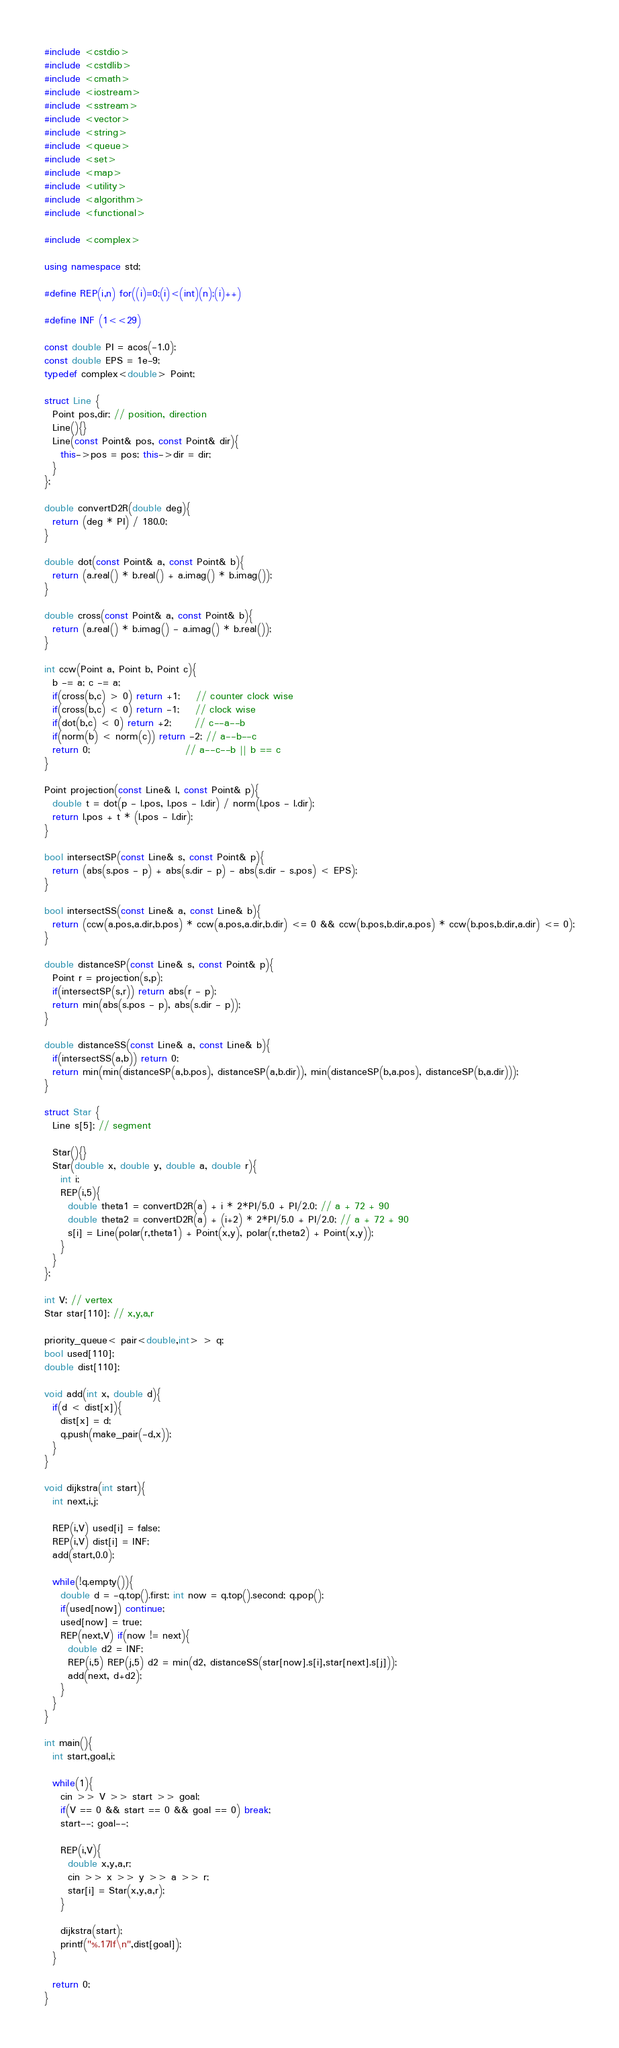<code> <loc_0><loc_0><loc_500><loc_500><_C++_>#include <cstdio>
#include <cstdlib>
#include <cmath>
#include <iostream>
#include <sstream>
#include <vector>
#include <string>
#include <queue>
#include <set>
#include <map>
#include <utility>
#include <algorithm>
#include <functional>

#include <complex>

using namespace std;

#define REP(i,n) for((i)=0;(i)<(int)(n);(i)++)

#define INF (1<<29)

const double PI = acos(-1.0);
const double EPS = 1e-9;
typedef complex<double> Point;

struct Line {
  Point pos,dir; // position, direction
  Line(){}
  Line(const Point& pos, const Point& dir){
    this->pos = pos; this->dir = dir;
  }
};

double convertD2R(double deg){
  return (deg * PI) / 180.0;
}

double dot(const Point& a, const Point& b){
  return (a.real() * b.real() + a.imag() * b.imag());
}

double cross(const Point& a, const Point& b){
  return (a.real() * b.imag() - a.imag() * b.real());
}

int ccw(Point a, Point b, Point c){
  b -= a; c -= a;
  if(cross(b,c) > 0) return +1;    // counter clock wise
  if(cross(b,c) < 0) return -1;    // clock wise
  if(dot(b,c) < 0) return +2;      // c--a--b
  if(norm(b) < norm(c)) return -2; // a--b--c
  return 0;                        // a--c--b || b == c
}

Point projection(const Line& l, const Point& p){
  double t = dot(p - l.pos, l.pos - l.dir) / norm(l.pos - l.dir);
  return l.pos + t * (l.pos - l.dir);
}

bool intersectSP(const Line& s, const Point& p){
  return (abs(s.pos - p) + abs(s.dir - p) - abs(s.dir - s.pos) < EPS);
}

bool intersectSS(const Line& a, const Line& b){
  return (ccw(a.pos,a.dir,b.pos) * ccw(a.pos,a.dir,b.dir) <= 0 && ccw(b.pos,b.dir,a.pos) * ccw(b.pos,b.dir,a.dir) <= 0);
}

double distanceSP(const Line& s, const Point& p){
  Point r = projection(s,p);
  if(intersectSP(s,r)) return abs(r - p);
  return min(abs(s.pos - p), abs(s.dir - p));
}

double distanceSS(const Line& a, const Line& b){
  if(intersectSS(a,b)) return 0;
  return min(min(distanceSP(a,b.pos), distanceSP(a,b.dir)), min(distanceSP(b,a.pos), distanceSP(b,a.dir)));
}

struct Star {
  Line s[5]; // segment

  Star(){}
  Star(double x, double y, double a, double r){
    int i;
    REP(i,5){
      double theta1 = convertD2R(a) + i * 2*PI/5.0 + PI/2.0; // a + 72 + 90
      double theta2 = convertD2R(a) + (i+2) * 2*PI/5.0 + PI/2.0; // a + 72 + 90
      s[i] = Line(polar(r,theta1) + Point(x,y), polar(r,theta2) + Point(x,y));
    }
  }
};

int V; // vertex
Star star[110]; // x,y,a,r

priority_queue< pair<double,int> > q;
bool used[110];
double dist[110];

void add(int x, double d){
  if(d < dist[x]){
    dist[x] = d;
    q.push(make_pair(-d,x));
  }
}

void dijkstra(int start){
  int next,i,j;

  REP(i,V) used[i] = false;
  REP(i,V) dist[i] = INF;
  add(start,0.0);

  while(!q.empty()){
    double d = -q.top().first; int now = q.top().second; q.pop();
    if(used[now]) continue;
    used[now] = true;
    REP(next,V) if(now != next){
      double d2 = INF;
      REP(i,5) REP(j,5) d2 = min(d2, distanceSS(star[now].s[i],star[next].s[j]));
      add(next, d+d2);
    }
  }
}

int main(){
  int start,goal,i;

  while(1){
    cin >> V >> start >> goal;
    if(V == 0 && start == 0 && goal == 0) break;
    start--; goal--;

    REP(i,V){
      double x,y,a,r;
      cin >> x >> y >> a >> r;
      star[i] = Star(x,y,a,r);
    }

    dijkstra(start);
    printf("%.17lf\n",dist[goal]);
  }

  return 0;
}</code> 